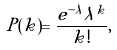<formula> <loc_0><loc_0><loc_500><loc_500>P ( k ) = \frac { e ^ { - \lambda } \lambda ^ { k } } { k ! } ,</formula> 